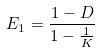<formula> <loc_0><loc_0><loc_500><loc_500>E _ { 1 } = \frac { 1 - D } { 1 - \frac { 1 } { K } }</formula> 